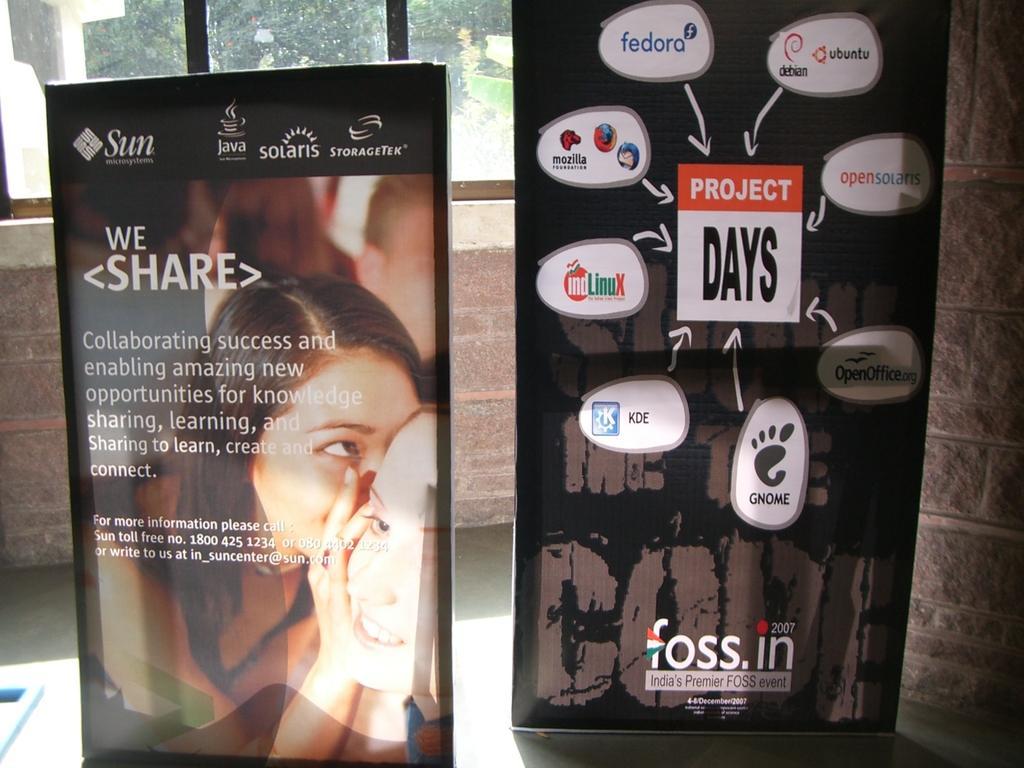Could you give a brief overview of what you see in this image? In the picture we can see inside the house with a glass window and near to it, we can see two hoardings which are placed on the path with some advertisements on it. 